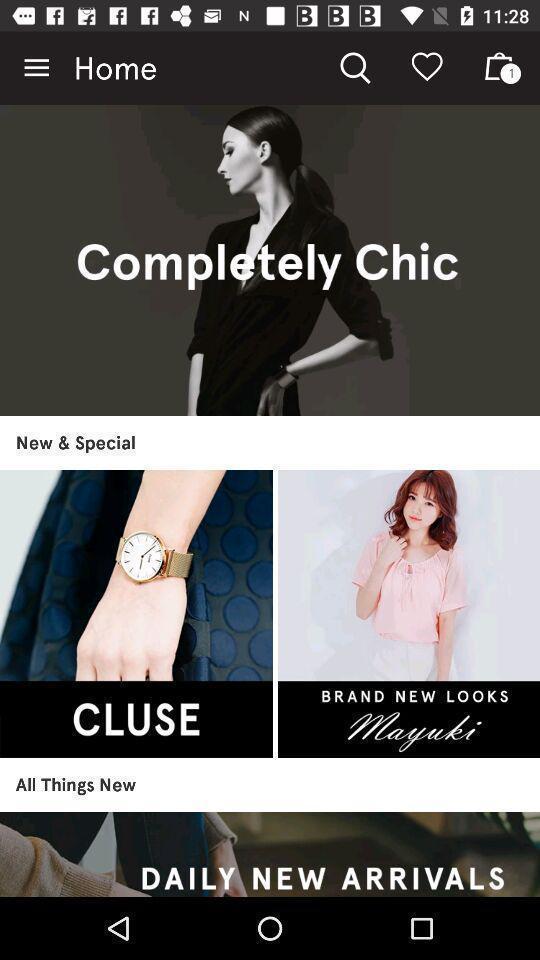Explain what's happening in this screen capture. Page showing list of items in shopping app. 